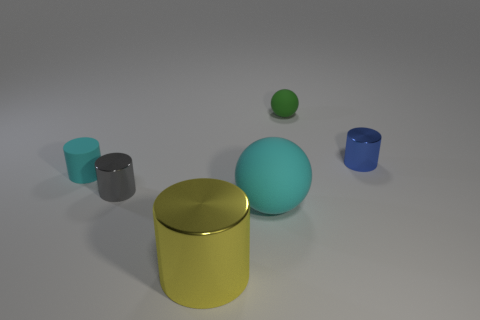Add 1 purple matte cylinders. How many objects exist? 7 Subtract all spheres. How many objects are left? 4 Subtract 0 gray cubes. How many objects are left? 6 Subtract all cyan matte spheres. Subtract all tiny cyan matte things. How many objects are left? 4 Add 5 large cyan rubber objects. How many large cyan rubber objects are left? 6 Add 6 tiny metallic cylinders. How many tiny metallic cylinders exist? 8 